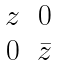Convert formula to latex. <formula><loc_0><loc_0><loc_500><loc_500>\begin{matrix} z & 0 \\ 0 & \bar { z } \end{matrix}</formula> 